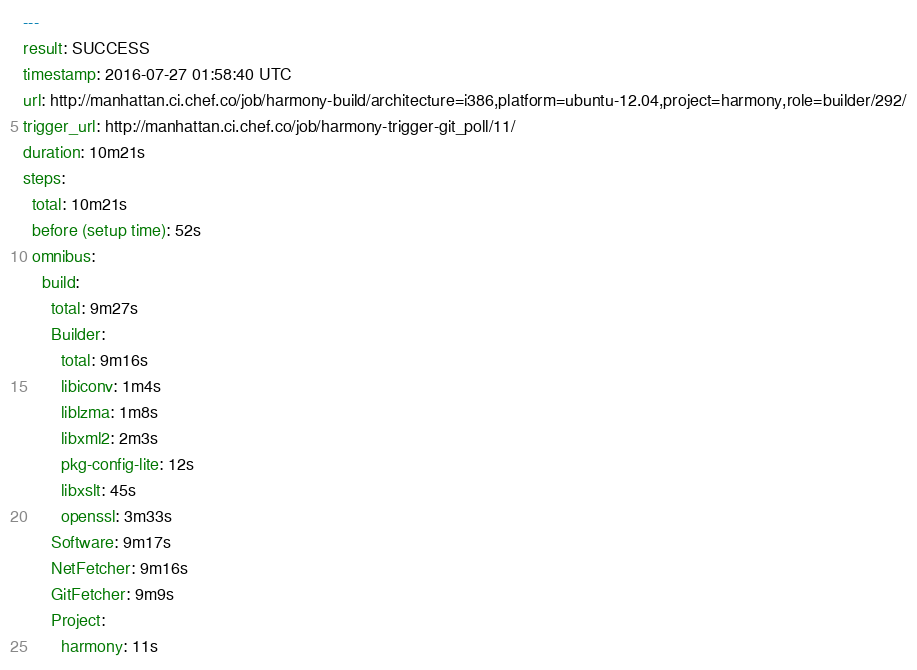<code> <loc_0><loc_0><loc_500><loc_500><_YAML_>---
result: SUCCESS
timestamp: 2016-07-27 01:58:40 UTC
url: http://manhattan.ci.chef.co/job/harmony-build/architecture=i386,platform=ubuntu-12.04,project=harmony,role=builder/292/
trigger_url: http://manhattan.ci.chef.co/job/harmony-trigger-git_poll/11/
duration: 10m21s
steps:
  total: 10m21s
  before (setup time): 52s
  omnibus:
    build:
      total: 9m27s
      Builder:
        total: 9m16s
        libiconv: 1m4s
        liblzma: 1m8s
        libxml2: 2m3s
        pkg-config-lite: 12s
        libxslt: 45s
        openssl: 3m33s
      Software: 9m17s
      NetFetcher: 9m16s
      GitFetcher: 9m9s
      Project:
        harmony: 11s
</code> 